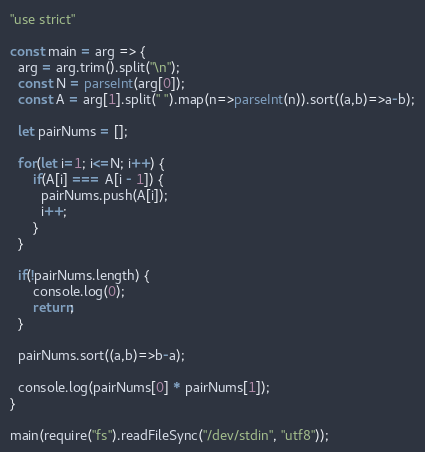Convert code to text. <code><loc_0><loc_0><loc_500><loc_500><_JavaScript_>"use strict"

const main = arg => {
  arg = arg.trim().split("\n");
  const N = parseInt(arg[0]);
  const A = arg[1].split(" ").map(n=>parseInt(n)).sort((a,b)=>a-b);
  
  let pairNums = [];

  for(let i=1; i<=N; i++) {
      if(A[i] === A[i - 1]) {
        pairNums.push(A[i]);
        i++;
      }
  }
  
  if(!pairNums.length) {
      console.log(0);
      return;
  }
  
  pairNums.sort((a,b)=>b-a);
  
  console.log(pairNums[0] * pairNums[1]);
}

main(require("fs").readFileSync("/dev/stdin", "utf8"));
</code> 